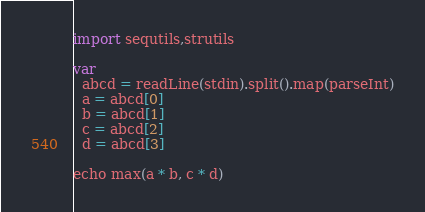Convert code to text. <code><loc_0><loc_0><loc_500><loc_500><_Nim_>import sequtils,strutils

var
  abcd = readLine(stdin).split().map(parseInt)
  a = abcd[0]
  b = abcd[1]
  c = abcd[2]
  d = abcd[3]

echo max(a * b, c * d)</code> 